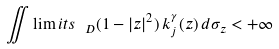Convert formula to latex. <formula><loc_0><loc_0><loc_500><loc_500>\iint \lim i t s _ { \ D } ( 1 - | z | ^ { 2 } ) \, k _ { j } ^ { \gamma } ( z ) \, d \sigma _ { z } < + \infty</formula> 